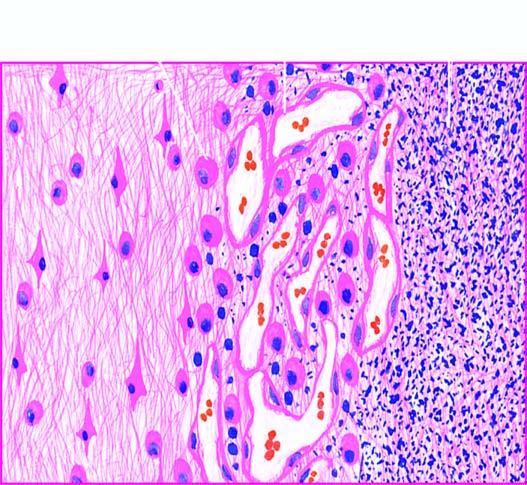does there show a cystic space containing cell debris, while the surrounding zone shows granulation tissue and gliosis?
Answer the question using a single word or phrase. No 